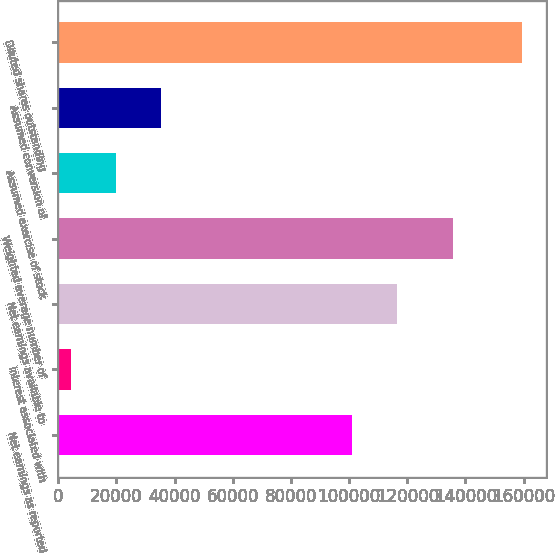Convert chart. <chart><loc_0><loc_0><loc_500><loc_500><bar_chart><fcel>Net earnings as reported<fcel>Interest associated with<fcel>Net earnings available to<fcel>Weighted average number of<fcel>Assumed exercise of stock<fcel>Assumed conversion of<fcel>Diluted shares outstanding<nl><fcel>100896<fcel>4377<fcel>116414<fcel>135691<fcel>19894.8<fcel>35412.6<fcel>159555<nl></chart> 